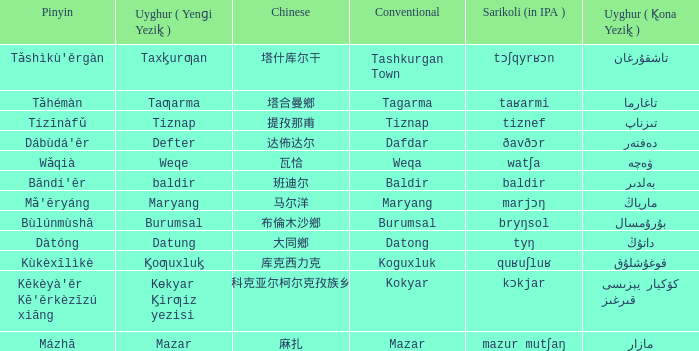Name the conventional for تاغارما Tagarma. 